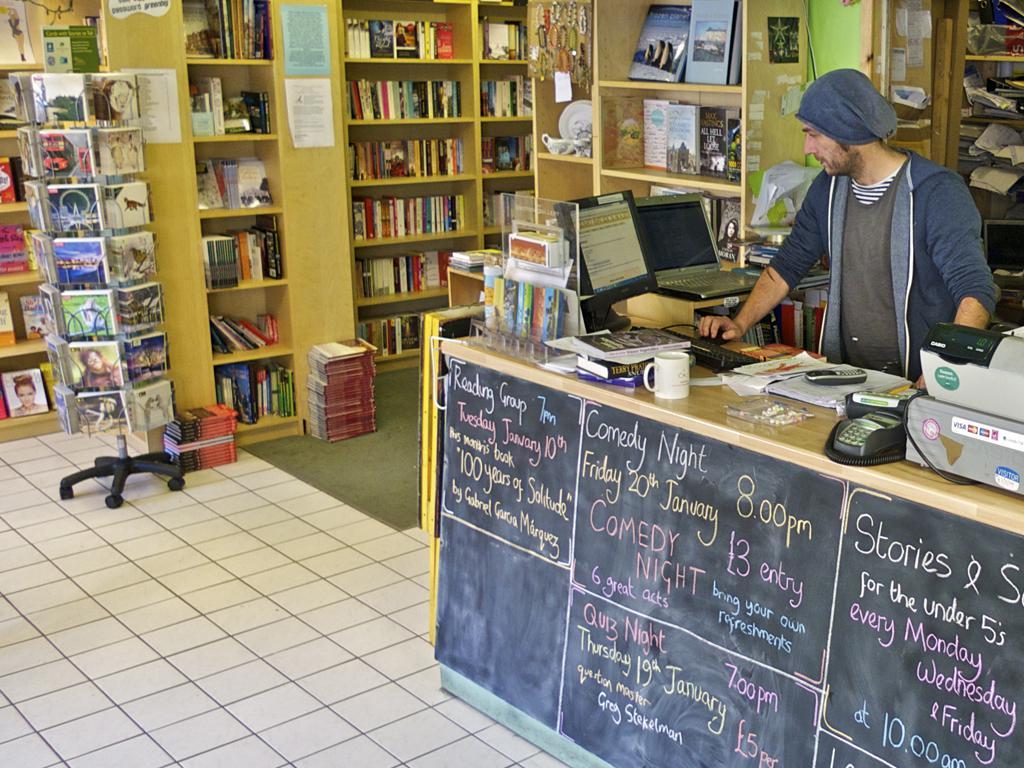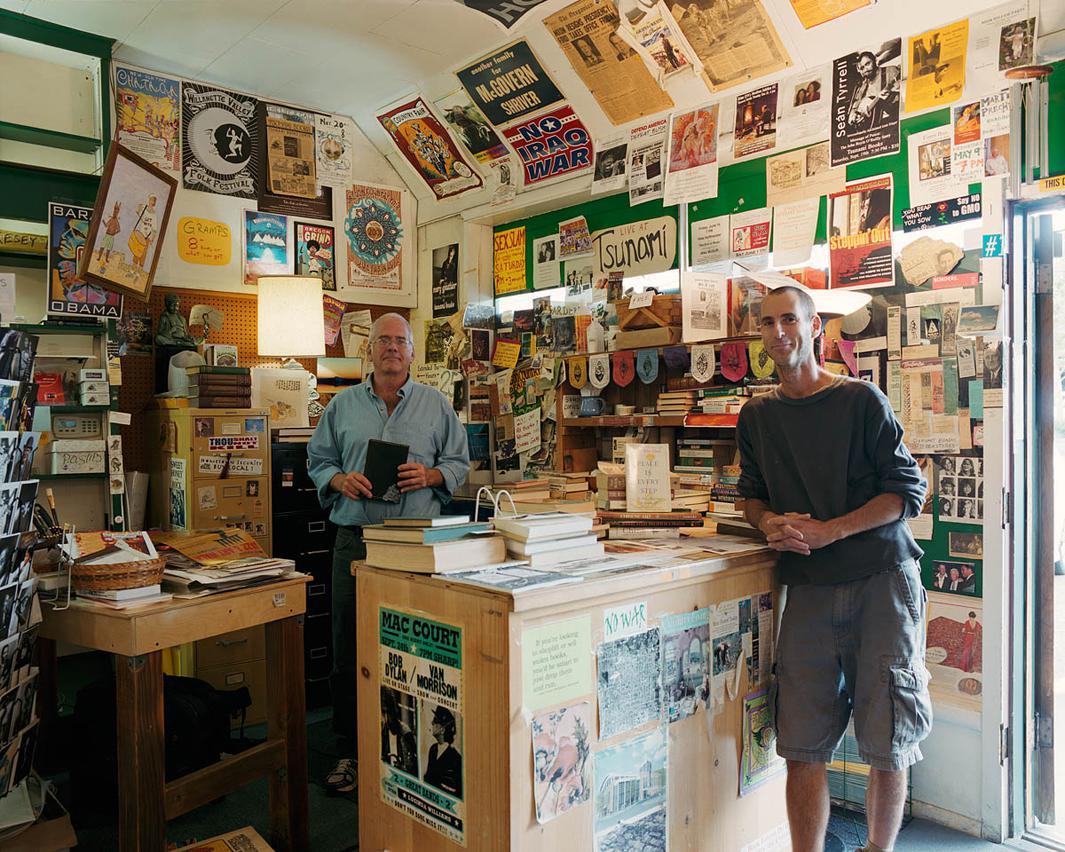The first image is the image on the left, the second image is the image on the right. Given the left and right images, does the statement "There are multiple people in a shop in the right image." hold true? Answer yes or no. Yes. The first image is the image on the left, the second image is the image on the right. Assess this claim about the two images: "There are three people in a bookstore.". Correct or not? Answer yes or no. Yes. 